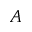Convert formula to latex. <formula><loc_0><loc_0><loc_500><loc_500>A</formula> 